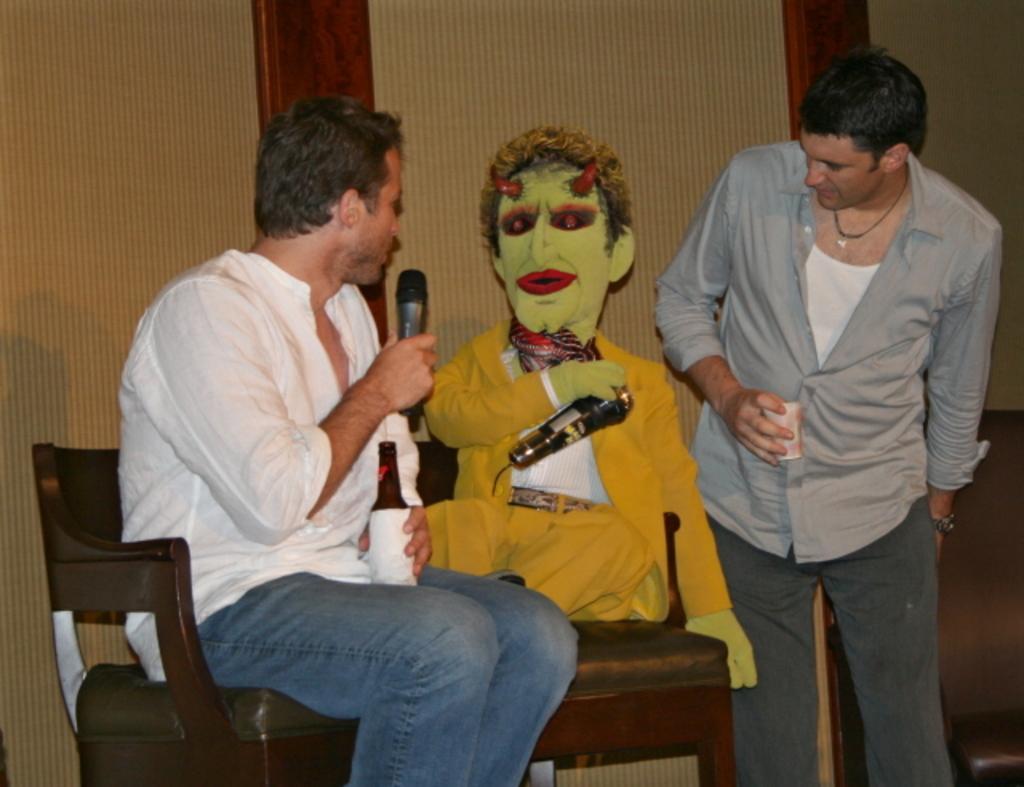In one or two sentences, can you explain what this image depicts? In this image i can see a man sitting on chair and holding a microphone and a man standing and looking at a doll at the back ground i can see a wall. 